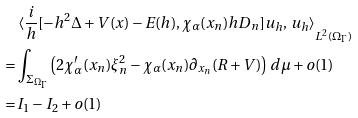<formula> <loc_0><loc_0><loc_500><loc_500>& \left < \frac { i } h [ - h ^ { 2 } \Delta + V ( x ) - E ( h ) , \chi _ { \alpha } ( x _ { n } ) h D _ { n } ] u _ { h } , \, u _ { h } \right > _ { L ^ { 2 } ( \Omega _ { \Gamma } ) } \\ = & \int _ { \Sigma _ { \Omega _ { \Gamma } } } \left ( 2 \chi _ { \alpha } ^ { \prime } ( x _ { n } ) \xi _ { n } ^ { 2 } - \chi _ { \alpha } ( x _ { n } ) \partial _ { x _ { n } } ( R + V ) \right ) \, d \mu + o ( 1 ) \\ = & I _ { 1 } - I _ { 2 } + o ( 1 )</formula> 